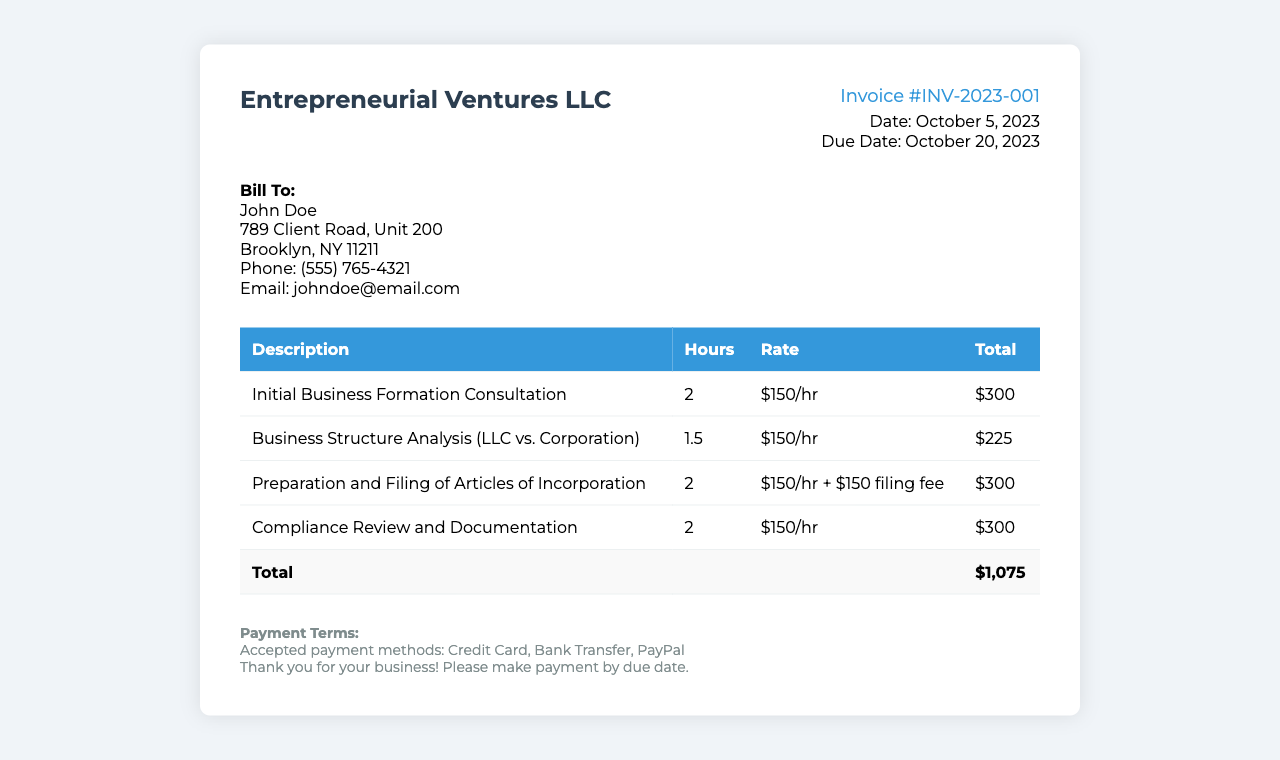What is the invoice number? The invoice number is listed in the document, which is INV-2023-001.
Answer: INV-2023-001 What is the total amount due? The total amount due is found in the total row of the invoice, which states $1,075.
Answer: $1,075 What is the consultation rate per hour? The rate per hour for consultation is specified throughout the document as $150/hr.
Answer: $150/hr When is the due date for payment? The due date for payment is clearly mentioned in the invoice, which is October 20, 2023.
Answer: October 20, 2023 How many hours were spent on compliance review? The hours spent on compliance review are listed in the table, specifically noted as 2 hours.
Answer: 2 Which filing fee is included in the invoice? The invoice mentions a specific filing fee of $150 included in the total for the Preparation and Filing of Articles of Incorporation.
Answer: $150 Who is the client being billed? The client's name is stated in the client information section, which identifies John Doe.
Answer: John Doe What services were provided for business formation? The services related to business formation are detailed, including Initial Business Formation Consultation and Preparation of Articles of Incorporation.
Answer: Initial Business Formation Consultation, Preparation and Filing of Articles of Incorporation What payment methods are accepted? The accepted payment methods are listed as Credit Card, Bank Transfer, PayPal.
Answer: Credit Card, Bank Transfer, PayPal 